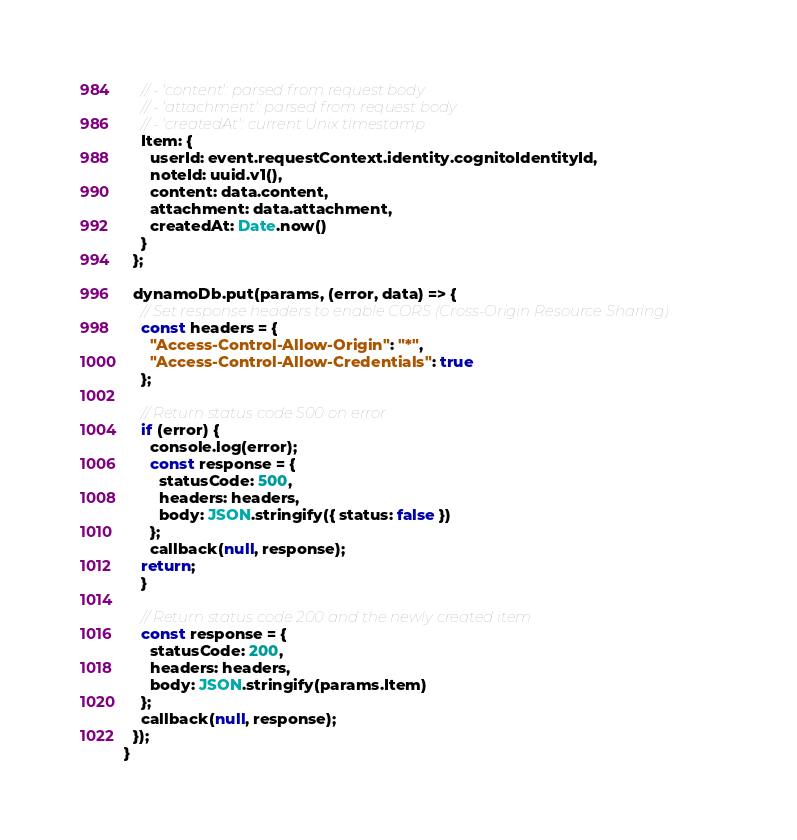Convert code to text. <code><loc_0><loc_0><loc_500><loc_500><_JavaScript_>    // - 'content': parsed from request body
    // - 'attachment': parsed from request body
    // - 'createdAt': current Unix timestamp
    Item: {
      userId: event.requestContext.identity.cognitoIdentityId,
      noteId: uuid.v1(),
      content: data.content,
      attachment: data.attachment,
      createdAt: Date.now()
    }
  };

  dynamoDb.put(params, (error, data) => {
    // Set response headers to enable CORS (Cross-Origin Resource Sharing)
    const headers = {
      "Access-Control-Allow-Origin": "*",
      "Access-Control-Allow-Credentials": true
    };

    // Return status code 500 on error
    if (error) {
      console.log(error);
      const response = {
        statusCode: 500,
        headers: headers,
        body: JSON.stringify({ status: false })
      };
      callback(null, response);
    return;
    }

    // Return status code 200 and the newly created item
    const response = {
      statusCode: 200,
      headers: headers,
      body: JSON.stringify(params.Item)
    };
    callback(null, response);
  });
}
</code> 